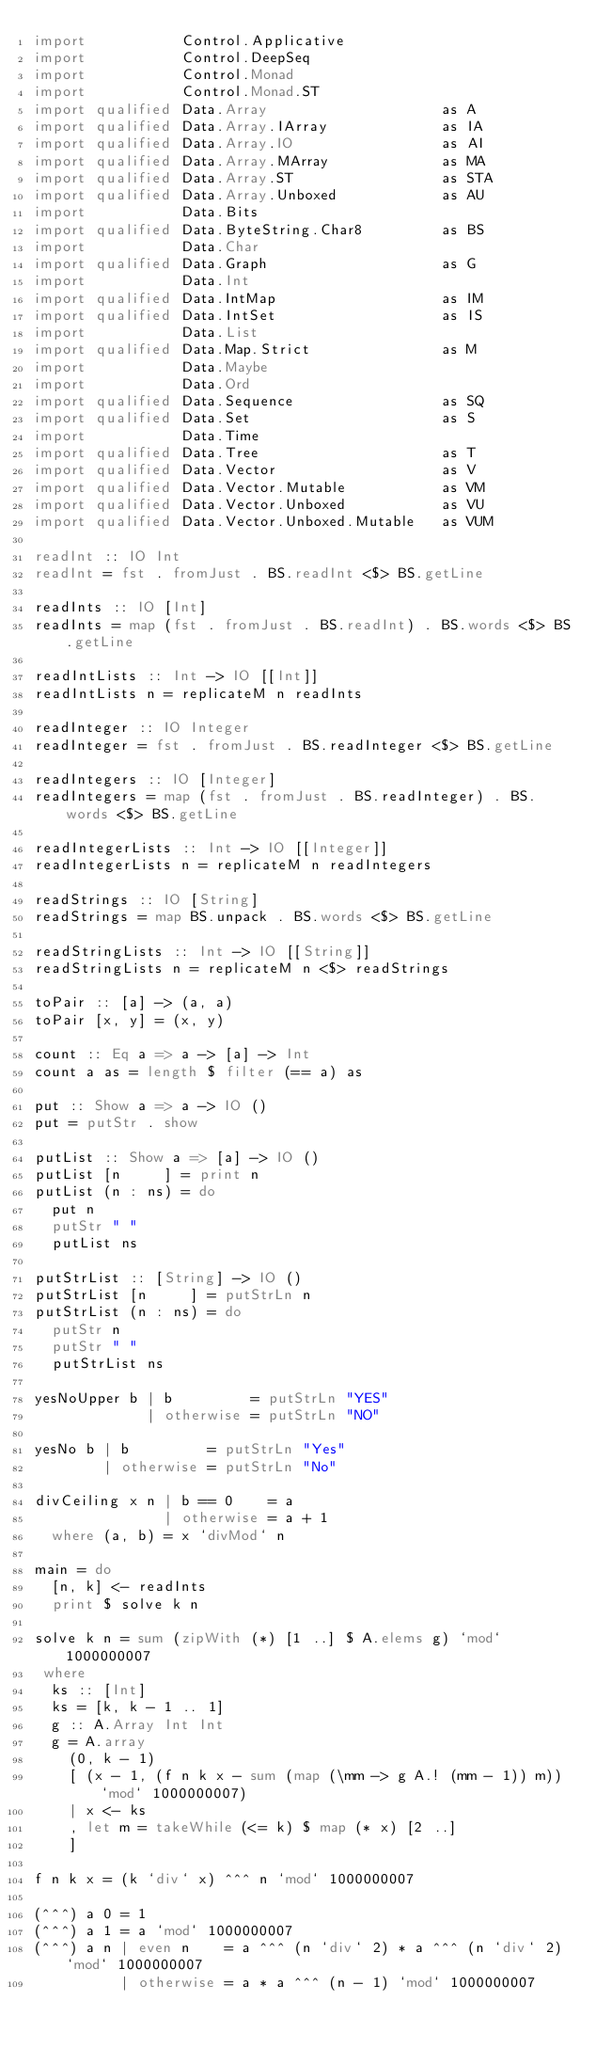<code> <loc_0><loc_0><loc_500><loc_500><_Haskell_>import           Control.Applicative
import           Control.DeepSeq
import           Control.Monad
import           Control.Monad.ST
import qualified Data.Array                    as A
import qualified Data.Array.IArray             as IA
import qualified Data.Array.IO                 as AI
import qualified Data.Array.MArray             as MA
import qualified Data.Array.ST                 as STA
import qualified Data.Array.Unboxed            as AU
import           Data.Bits
import qualified Data.ByteString.Char8         as BS
import           Data.Char
import qualified Data.Graph                    as G
import           Data.Int
import qualified Data.IntMap                   as IM
import qualified Data.IntSet                   as IS
import           Data.List
import qualified Data.Map.Strict               as M
import           Data.Maybe
import           Data.Ord
import qualified Data.Sequence                 as SQ
import qualified Data.Set                      as S
import           Data.Time
import qualified Data.Tree                     as T
import qualified Data.Vector                   as V
import qualified Data.Vector.Mutable           as VM
import qualified Data.Vector.Unboxed           as VU
import qualified Data.Vector.Unboxed.Mutable   as VUM

readInt :: IO Int
readInt = fst . fromJust . BS.readInt <$> BS.getLine

readInts :: IO [Int]
readInts = map (fst . fromJust . BS.readInt) . BS.words <$> BS.getLine

readIntLists :: Int -> IO [[Int]]
readIntLists n = replicateM n readInts

readInteger :: IO Integer
readInteger = fst . fromJust . BS.readInteger <$> BS.getLine

readIntegers :: IO [Integer]
readIntegers = map (fst . fromJust . BS.readInteger) . BS.words <$> BS.getLine

readIntegerLists :: Int -> IO [[Integer]]
readIntegerLists n = replicateM n readIntegers

readStrings :: IO [String]
readStrings = map BS.unpack . BS.words <$> BS.getLine

readStringLists :: Int -> IO [[String]]
readStringLists n = replicateM n <$> readStrings

toPair :: [a] -> (a, a)
toPair [x, y] = (x, y)

count :: Eq a => a -> [a] -> Int
count a as = length $ filter (== a) as

put :: Show a => a -> IO ()
put = putStr . show

putList :: Show a => [a] -> IO ()
putList [n     ] = print n
putList (n : ns) = do
  put n
  putStr " "
  putList ns

putStrList :: [String] -> IO ()
putStrList [n     ] = putStrLn n
putStrList (n : ns) = do
  putStr n
  putStr " "
  putStrList ns

yesNoUpper b | b         = putStrLn "YES"
             | otherwise = putStrLn "NO"

yesNo b | b         = putStrLn "Yes"
        | otherwise = putStrLn "No"

divCeiling x n | b == 0    = a
               | otherwise = a + 1
  where (a, b) = x `divMod` n

main = do
  [n, k] <- readInts
  print $ solve k n

solve k n = sum (zipWith (*) [1 ..] $ A.elems g) `mod` 1000000007
 where
  ks :: [Int]
  ks = [k, k - 1 .. 1]
  g :: A.Array Int Int
  g = A.array
    (0, k - 1)
    [ (x - 1, (f n k x - sum (map (\mm -> g A.! (mm - 1)) m)) `mod` 1000000007)
    | x <- ks
    , let m = takeWhile (<= k) $ map (* x) [2 ..]
    ]

f n k x = (k `div` x) ^^^ n `mod` 1000000007

(^^^) a 0 = 1
(^^^) a 1 = a `mod` 1000000007
(^^^) a n | even n    = a ^^^ (n `div` 2) * a ^^^ (n `div` 2) `mod` 1000000007
          | otherwise = a * a ^^^ (n - 1) `mod` 1000000007
</code> 